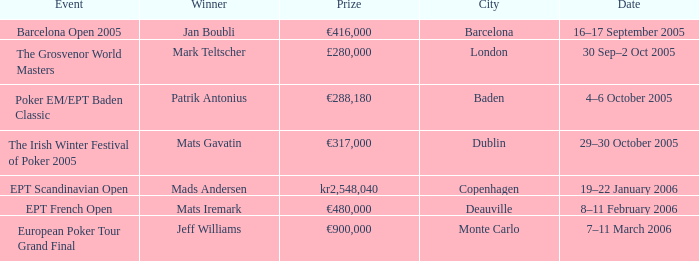What city did an event have a prize of €288,180? Baden. Help me parse the entirety of this table. {'header': ['Event', 'Winner', 'Prize', 'City', 'Date'], 'rows': [['Barcelona Open 2005', 'Jan Boubli', '€416,000', 'Barcelona', '16–17 September 2005'], ['The Grosvenor World Masters', 'Mark Teltscher', '£280,000', 'London', '30 Sep–2 Oct 2005'], ['Poker EM/EPT Baden Classic', 'Patrik Antonius', '€288,180', 'Baden', '4–6 October 2005'], ['The Irish Winter Festival of Poker 2005', 'Mats Gavatin', '€317,000', 'Dublin', '29–30 October 2005'], ['EPT Scandinavian Open', 'Mads Andersen', 'kr2,548,040', 'Copenhagen', '19–22 January 2006'], ['EPT French Open', 'Mats Iremark', '€480,000', 'Deauville', '8–11 February 2006'], ['European Poker Tour Grand Final', 'Jeff Williams', '€900,000', 'Monte Carlo', '7–11 March 2006']]} 